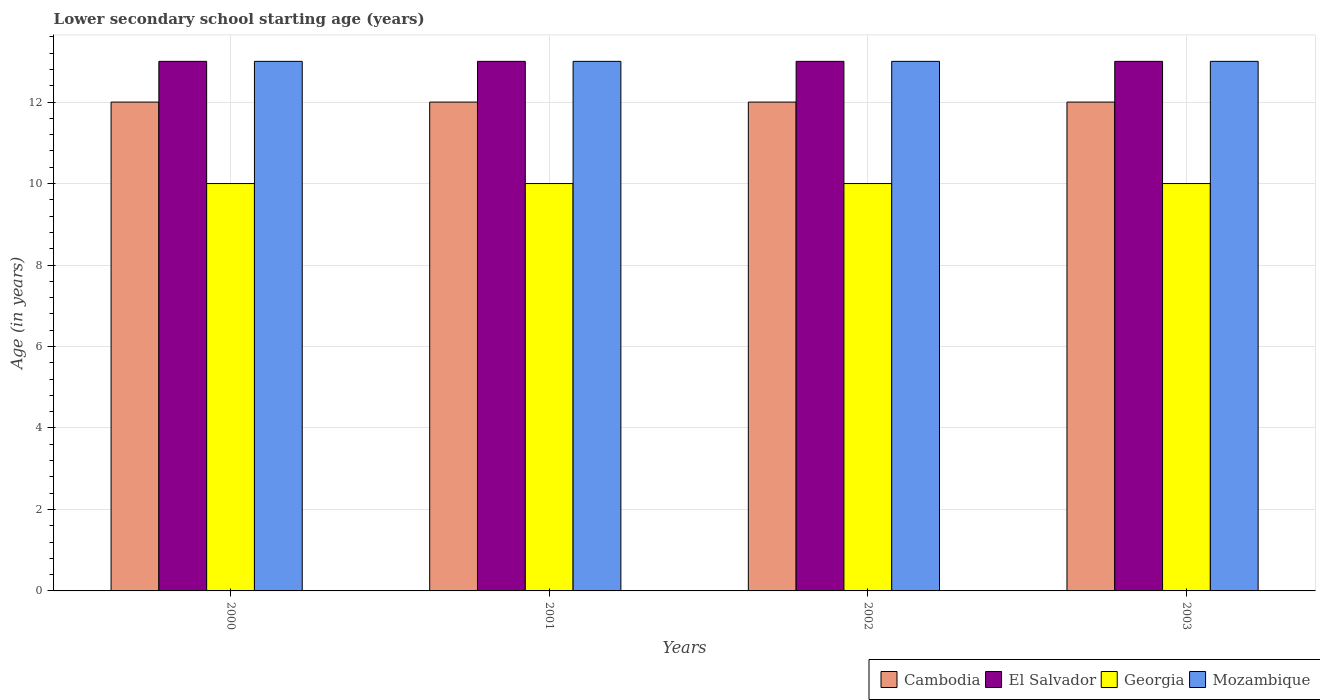How many different coloured bars are there?
Make the answer very short. 4. Are the number of bars on each tick of the X-axis equal?
Offer a terse response. Yes. How many bars are there on the 3rd tick from the left?
Give a very brief answer. 4. How many bars are there on the 2nd tick from the right?
Offer a terse response. 4. What is the lower secondary school starting age of children in El Salvador in 2003?
Offer a terse response. 13. Across all years, what is the maximum lower secondary school starting age of children in Georgia?
Keep it short and to the point. 10. Across all years, what is the minimum lower secondary school starting age of children in Georgia?
Provide a short and direct response. 10. In which year was the lower secondary school starting age of children in Mozambique maximum?
Your response must be concise. 2000. What is the total lower secondary school starting age of children in Mozambique in the graph?
Ensure brevity in your answer.  52. What is the difference between the lower secondary school starting age of children in El Salvador in 2000 and the lower secondary school starting age of children in Georgia in 2001?
Provide a succinct answer. 3. What is the average lower secondary school starting age of children in Cambodia per year?
Provide a succinct answer. 12. In the year 2000, what is the difference between the lower secondary school starting age of children in Georgia and lower secondary school starting age of children in Mozambique?
Make the answer very short. -3. What is the ratio of the lower secondary school starting age of children in Mozambique in 2001 to that in 2003?
Provide a short and direct response. 1. Is the lower secondary school starting age of children in Cambodia in 2002 less than that in 2003?
Keep it short and to the point. No. What is the difference between the highest and the second highest lower secondary school starting age of children in Mozambique?
Your answer should be compact. 0. What is the difference between the highest and the lowest lower secondary school starting age of children in Georgia?
Ensure brevity in your answer.  0. In how many years, is the lower secondary school starting age of children in Cambodia greater than the average lower secondary school starting age of children in Cambodia taken over all years?
Keep it short and to the point. 0. Is the sum of the lower secondary school starting age of children in Georgia in 2000 and 2001 greater than the maximum lower secondary school starting age of children in Cambodia across all years?
Your answer should be compact. Yes. Is it the case that in every year, the sum of the lower secondary school starting age of children in Cambodia and lower secondary school starting age of children in Mozambique is greater than the sum of lower secondary school starting age of children in El Salvador and lower secondary school starting age of children in Georgia?
Make the answer very short. No. What does the 2nd bar from the left in 2000 represents?
Your answer should be very brief. El Salvador. What does the 2nd bar from the right in 2001 represents?
Offer a terse response. Georgia. Is it the case that in every year, the sum of the lower secondary school starting age of children in Cambodia and lower secondary school starting age of children in Georgia is greater than the lower secondary school starting age of children in El Salvador?
Give a very brief answer. Yes. How many bars are there?
Offer a terse response. 16. Are all the bars in the graph horizontal?
Ensure brevity in your answer.  No. How many years are there in the graph?
Make the answer very short. 4. Does the graph contain any zero values?
Your answer should be very brief. No. Does the graph contain grids?
Offer a terse response. Yes. What is the title of the graph?
Provide a succinct answer. Lower secondary school starting age (years). What is the label or title of the Y-axis?
Give a very brief answer. Age (in years). What is the Age (in years) in Cambodia in 2000?
Your answer should be compact. 12. What is the Age (in years) in El Salvador in 2000?
Provide a short and direct response. 13. What is the Age (in years) in Mozambique in 2000?
Give a very brief answer. 13. What is the Age (in years) of El Salvador in 2002?
Provide a succinct answer. 13. What is the Age (in years) in Mozambique in 2002?
Keep it short and to the point. 13. What is the Age (in years) of Cambodia in 2003?
Make the answer very short. 12. What is the Age (in years) of Georgia in 2003?
Provide a short and direct response. 10. Across all years, what is the maximum Age (in years) in Cambodia?
Provide a succinct answer. 12. Across all years, what is the maximum Age (in years) in El Salvador?
Your answer should be very brief. 13. Across all years, what is the maximum Age (in years) in Georgia?
Provide a short and direct response. 10. Across all years, what is the minimum Age (in years) in Cambodia?
Your answer should be very brief. 12. Across all years, what is the minimum Age (in years) in Georgia?
Your response must be concise. 10. Across all years, what is the minimum Age (in years) of Mozambique?
Offer a terse response. 13. What is the total Age (in years) in Cambodia in the graph?
Make the answer very short. 48. What is the total Age (in years) in El Salvador in the graph?
Provide a succinct answer. 52. What is the difference between the Age (in years) of Mozambique in 2000 and that in 2001?
Give a very brief answer. 0. What is the difference between the Age (in years) of El Salvador in 2000 and that in 2003?
Ensure brevity in your answer.  0. What is the difference between the Age (in years) of Georgia in 2000 and that in 2003?
Offer a very short reply. 0. What is the difference between the Age (in years) in Mozambique in 2000 and that in 2003?
Your answer should be compact. 0. What is the difference between the Age (in years) of Cambodia in 2001 and that in 2003?
Provide a short and direct response. 0. What is the difference between the Age (in years) of El Salvador in 2001 and that in 2003?
Your answer should be compact. 0. What is the difference between the Age (in years) of Georgia in 2001 and that in 2003?
Give a very brief answer. 0. What is the difference between the Age (in years) of Cambodia in 2002 and that in 2003?
Your answer should be compact. 0. What is the difference between the Age (in years) of El Salvador in 2002 and that in 2003?
Ensure brevity in your answer.  0. What is the difference between the Age (in years) in Georgia in 2002 and that in 2003?
Make the answer very short. 0. What is the difference between the Age (in years) of Cambodia in 2000 and the Age (in years) of Georgia in 2001?
Provide a short and direct response. 2. What is the difference between the Age (in years) in Cambodia in 2000 and the Age (in years) in Mozambique in 2001?
Provide a short and direct response. -1. What is the difference between the Age (in years) of El Salvador in 2000 and the Age (in years) of Georgia in 2001?
Provide a succinct answer. 3. What is the difference between the Age (in years) in Cambodia in 2000 and the Age (in years) in Georgia in 2002?
Keep it short and to the point. 2. What is the difference between the Age (in years) of Cambodia in 2000 and the Age (in years) of Mozambique in 2002?
Your answer should be compact. -1. What is the difference between the Age (in years) of El Salvador in 2000 and the Age (in years) of Georgia in 2002?
Ensure brevity in your answer.  3. What is the difference between the Age (in years) in El Salvador in 2000 and the Age (in years) in Mozambique in 2002?
Make the answer very short. 0. What is the difference between the Age (in years) in Cambodia in 2000 and the Age (in years) in El Salvador in 2003?
Provide a succinct answer. -1. What is the difference between the Age (in years) of El Salvador in 2000 and the Age (in years) of Georgia in 2003?
Provide a short and direct response. 3. What is the difference between the Age (in years) of Georgia in 2000 and the Age (in years) of Mozambique in 2003?
Provide a succinct answer. -3. What is the difference between the Age (in years) in Cambodia in 2001 and the Age (in years) in El Salvador in 2002?
Ensure brevity in your answer.  -1. What is the difference between the Age (in years) in Cambodia in 2001 and the Age (in years) in Mozambique in 2002?
Give a very brief answer. -1. What is the difference between the Age (in years) in Georgia in 2001 and the Age (in years) in Mozambique in 2002?
Your answer should be very brief. -3. What is the difference between the Age (in years) of Cambodia in 2001 and the Age (in years) of El Salvador in 2003?
Make the answer very short. -1. What is the difference between the Age (in years) in Cambodia in 2001 and the Age (in years) in Georgia in 2003?
Offer a very short reply. 2. What is the difference between the Age (in years) in El Salvador in 2001 and the Age (in years) in Georgia in 2003?
Your response must be concise. 3. What is the difference between the Age (in years) in El Salvador in 2001 and the Age (in years) in Mozambique in 2003?
Ensure brevity in your answer.  0. What is the difference between the Age (in years) in Cambodia in 2002 and the Age (in years) in Mozambique in 2003?
Offer a terse response. -1. What is the difference between the Age (in years) of El Salvador in 2002 and the Age (in years) of Mozambique in 2003?
Provide a short and direct response. 0. What is the average Age (in years) of Cambodia per year?
Provide a short and direct response. 12. What is the average Age (in years) in El Salvador per year?
Your answer should be very brief. 13. What is the average Age (in years) in Georgia per year?
Make the answer very short. 10. What is the average Age (in years) in Mozambique per year?
Provide a succinct answer. 13. In the year 2000, what is the difference between the Age (in years) of Cambodia and Age (in years) of Georgia?
Provide a short and direct response. 2. In the year 2000, what is the difference between the Age (in years) in Cambodia and Age (in years) in Mozambique?
Provide a succinct answer. -1. In the year 2000, what is the difference between the Age (in years) of El Salvador and Age (in years) of Mozambique?
Provide a short and direct response. 0. In the year 2001, what is the difference between the Age (in years) of Cambodia and Age (in years) of Georgia?
Your response must be concise. 2. In the year 2001, what is the difference between the Age (in years) in Georgia and Age (in years) in Mozambique?
Offer a very short reply. -3. In the year 2002, what is the difference between the Age (in years) in Cambodia and Age (in years) in El Salvador?
Keep it short and to the point. -1. In the year 2002, what is the difference between the Age (in years) of El Salvador and Age (in years) of Georgia?
Your answer should be compact. 3. In the year 2003, what is the difference between the Age (in years) in Cambodia and Age (in years) in El Salvador?
Your response must be concise. -1. In the year 2003, what is the difference between the Age (in years) of Cambodia and Age (in years) of Mozambique?
Ensure brevity in your answer.  -1. What is the ratio of the Age (in years) in Cambodia in 2000 to that in 2001?
Keep it short and to the point. 1. What is the ratio of the Age (in years) of Georgia in 2000 to that in 2001?
Offer a terse response. 1. What is the ratio of the Age (in years) in Cambodia in 2000 to that in 2002?
Ensure brevity in your answer.  1. What is the ratio of the Age (in years) in El Salvador in 2000 to that in 2002?
Keep it short and to the point. 1. What is the ratio of the Age (in years) in Cambodia in 2000 to that in 2003?
Your answer should be compact. 1. What is the ratio of the Age (in years) in El Salvador in 2000 to that in 2003?
Offer a very short reply. 1. What is the ratio of the Age (in years) in Georgia in 2000 to that in 2003?
Offer a terse response. 1. What is the ratio of the Age (in years) in Mozambique in 2000 to that in 2003?
Your answer should be compact. 1. What is the ratio of the Age (in years) in Georgia in 2001 to that in 2002?
Offer a very short reply. 1. What is the ratio of the Age (in years) in Cambodia in 2001 to that in 2003?
Ensure brevity in your answer.  1. What is the ratio of the Age (in years) of Cambodia in 2002 to that in 2003?
Your response must be concise. 1. What is the ratio of the Age (in years) of El Salvador in 2002 to that in 2003?
Provide a short and direct response. 1. What is the ratio of the Age (in years) in Mozambique in 2002 to that in 2003?
Provide a succinct answer. 1. What is the difference between the highest and the second highest Age (in years) in El Salvador?
Give a very brief answer. 0. What is the difference between the highest and the lowest Age (in years) in Cambodia?
Your answer should be very brief. 0. What is the difference between the highest and the lowest Age (in years) of El Salvador?
Your answer should be compact. 0. What is the difference between the highest and the lowest Age (in years) in Mozambique?
Keep it short and to the point. 0. 